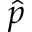<formula> <loc_0><loc_0><loc_500><loc_500>\hat { p }</formula> 